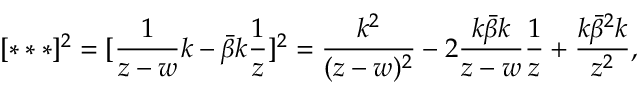<formula> <loc_0><loc_0><loc_500><loc_500>[ * * * ] ^ { 2 } = [ \frac { 1 } { z - w } k - \bar { \beta } k \frac { 1 } { z } ] ^ { 2 } = \frac { k ^ { 2 } } { ( z - w ) ^ { 2 } } - 2 \frac { k \bar { \beta } k } { z - w } \frac { 1 } { z } + \frac { k \bar { \beta } ^ { 2 } k } { z ^ { 2 } } ,</formula> 